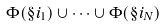<formula> <loc_0><loc_0><loc_500><loc_500>\Phi ( \S i _ { 1 } ) \cup \cdots \cup \Phi ( \S i _ { N } )</formula> 